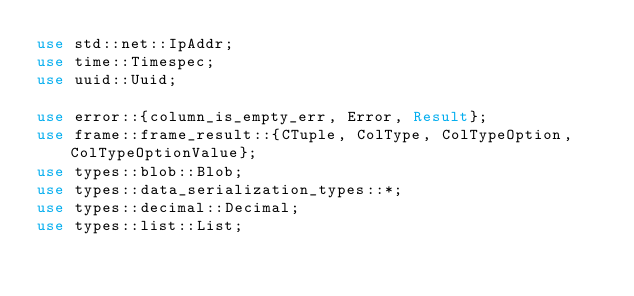Convert code to text. <code><loc_0><loc_0><loc_500><loc_500><_Rust_>use std::net::IpAddr;
use time::Timespec;
use uuid::Uuid;

use error::{column_is_empty_err, Error, Result};
use frame::frame_result::{CTuple, ColType, ColTypeOption, ColTypeOptionValue};
use types::blob::Blob;
use types::data_serialization_types::*;
use types::decimal::Decimal;
use types::list::List;</code> 